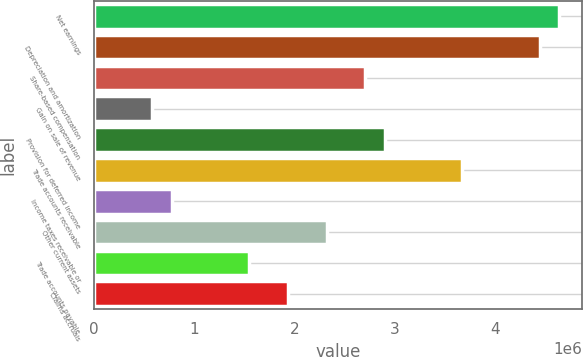Convert chart to OTSL. <chart><loc_0><loc_0><loc_500><loc_500><bar_chart><fcel>Net earnings<fcel>Depreciation and amortization<fcel>Share-based compensation<fcel>Gain on sale of revenue<fcel>Provision for deferred income<fcel>Trade accounts receivable<fcel>Income taxes receivable or<fcel>Other current assets<fcel>Trade accounts payable<fcel>Claims accruals<nl><fcel>4.64096e+06<fcel>4.44758e+06<fcel>2.70724e+06<fcel>580152<fcel>2.90061e+06<fcel>3.6741e+06<fcel>773523<fcel>2.3205e+06<fcel>1.54701e+06<fcel>1.93375e+06<nl></chart> 